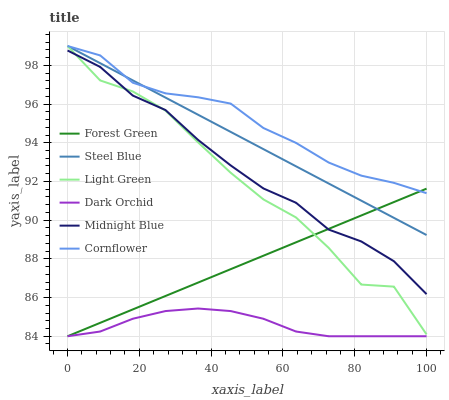Does Dark Orchid have the minimum area under the curve?
Answer yes or no. Yes. Does Cornflower have the maximum area under the curve?
Answer yes or no. Yes. Does Midnight Blue have the minimum area under the curve?
Answer yes or no. No. Does Midnight Blue have the maximum area under the curve?
Answer yes or no. No. Is Steel Blue the smoothest?
Answer yes or no. Yes. Is Light Green the roughest?
Answer yes or no. Yes. Is Midnight Blue the smoothest?
Answer yes or no. No. Is Midnight Blue the roughest?
Answer yes or no. No. Does Midnight Blue have the lowest value?
Answer yes or no. No. Does Light Green have the highest value?
Answer yes or no. Yes. Does Midnight Blue have the highest value?
Answer yes or no. No. Is Dark Orchid less than Cornflower?
Answer yes or no. Yes. Is Cornflower greater than Midnight Blue?
Answer yes or no. Yes. Does Dark Orchid intersect Cornflower?
Answer yes or no. No. 